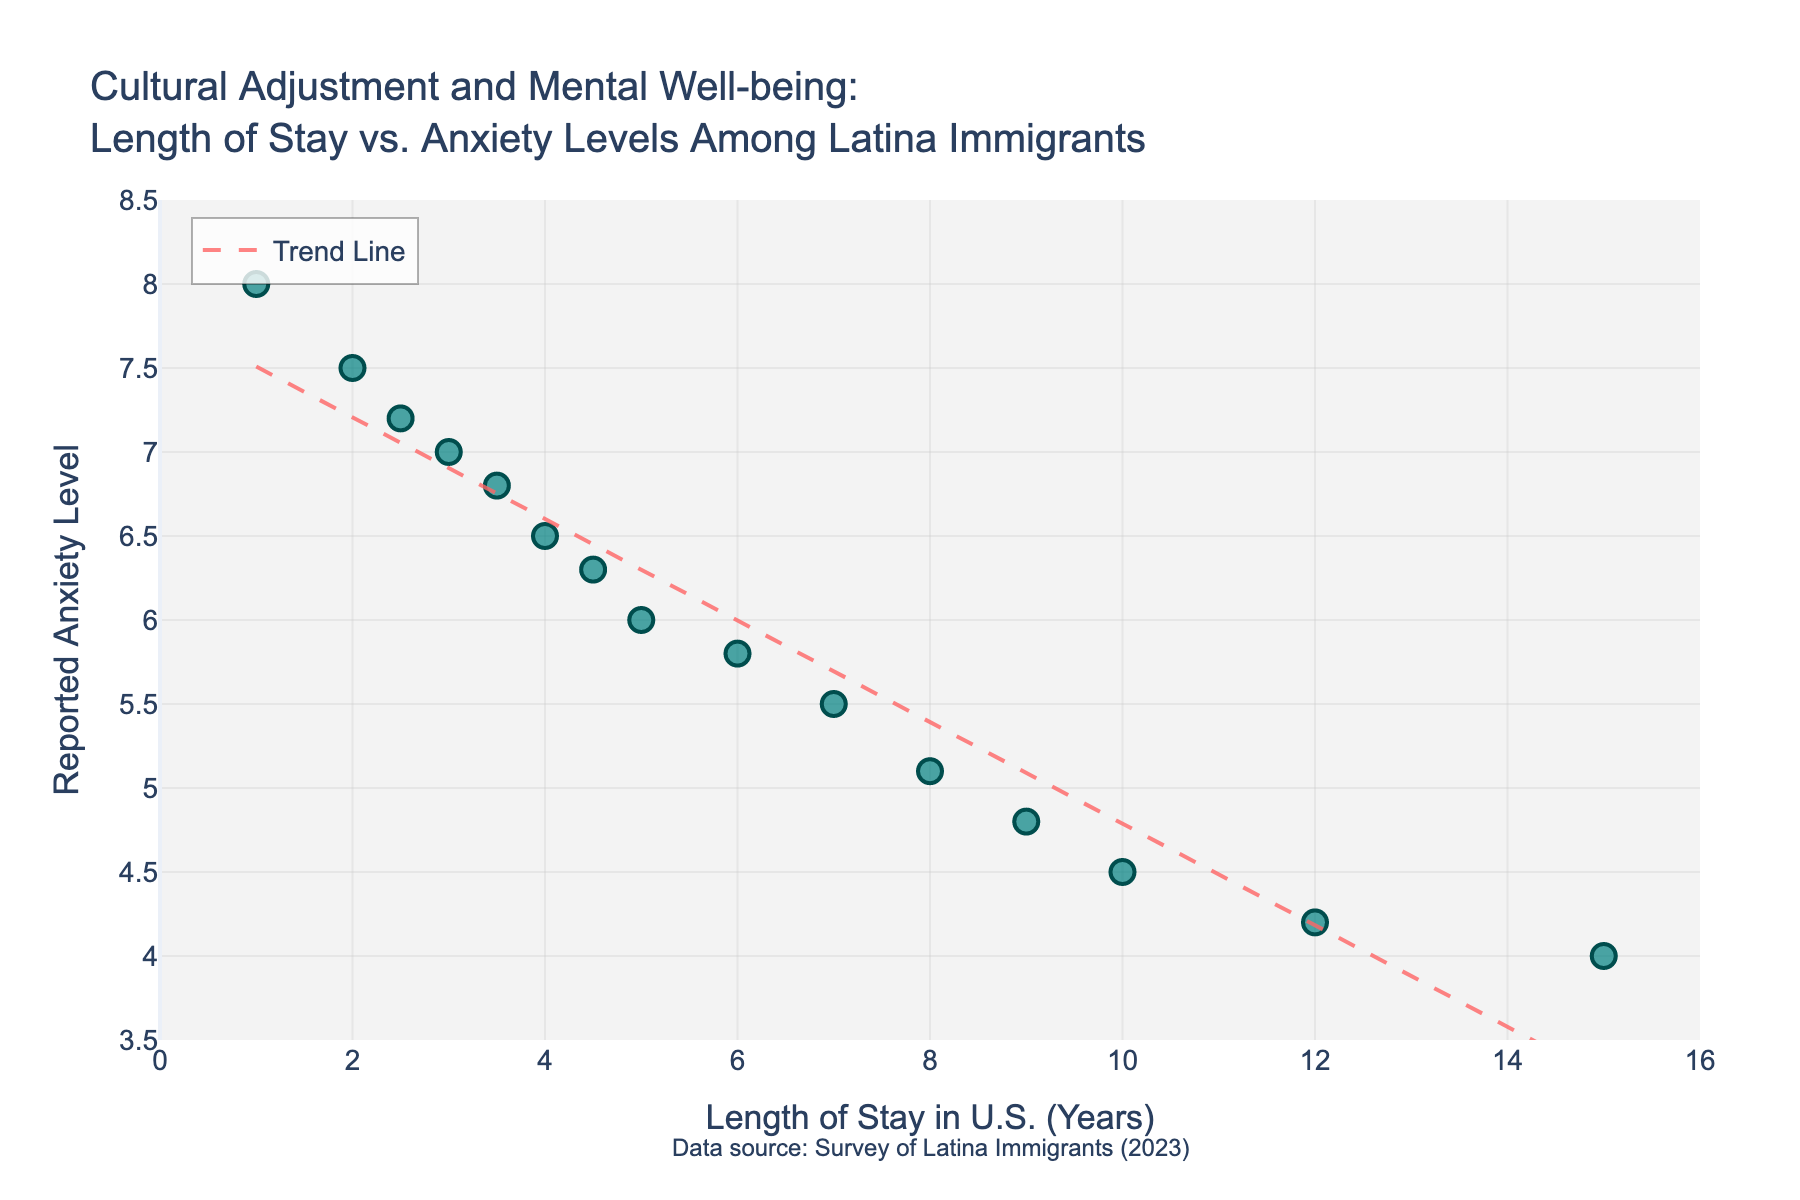What's the title of the plot? The title is typically at the top center of the plot. It is displayed prominently to give the viewer context about what the plot represents.
Answer: Cultural Adjustment and Mental Well-being: Length of Stay vs. Anxiety Levels Among Latina Immigrants What do the x and y axes represent? The x-axis is labeled "Length of Stay in U.S. (Years)" and represents the duration of stay in the U.S. for Latina immigrants. The y-axis is labeled "Reported Anxiety Level" and represents their self-reported anxiety levels.
Answer: Length of Stay in U.S. (Years) and Reported Anxiety Level How many data points are shown in the plot? To find the number of data points, count the markers displayed in the scatter plot.
Answer: 15 What is the trend shown by the trend line? The trend line represents a declining pattern, indicating that as the length of stay in the U.S. increases, the reported anxiety levels tend to decrease.
Answer: Anxiety decreases over time What is the reported anxiety level for those who have stayed in the U.S. for 4 years? Locate the data point corresponding to 4 years on the x-axis and find its y-value, which represents the reported anxiety level.
Answer: 6.5 Which data point has the highest reported anxiety level, and what is its corresponding length of stay? Find the highest y-value among the data points and identify its corresponding x-value.
Answer: 1 year, 8 Compare the anxiety levels between those who have stayed for 2 years and 10 years. Which is higher and by how much? Identify the y-values for both 2 years and 10 years and calculate their difference. Anxiety level for 2 years is 7.5 and for 10 years is 4.5, the difference is 7.5 - 4.5 = 3.
Answer: 2 years by 3 What is the average reported anxiety level for those who have stayed in the U.S. for 5 years or longer? Find the y-values for data points with x-values greater than or equal to 5 years, sum them up, and divide by the number of such data points. Mean calculation: (6 + 5.8 + 5.5 + 5.1 + 4.8 + 4.5 + 4.2 + 4) / 8 = (35.9 / 8) = 4.49
Answer: 4.49 Is there any data point exactly on the trend line? Observing if any of the markers align perfectly with the trend line.
Answer: No How does the trend line help in interpreting the data? It provides a clearer understanding of the overall pattern, showing that anxiety levels decrease with a longer stay, thus aiding in recognizing the broader trend over individual variations.
Answer: Shows overall decreasing anxiety trend 